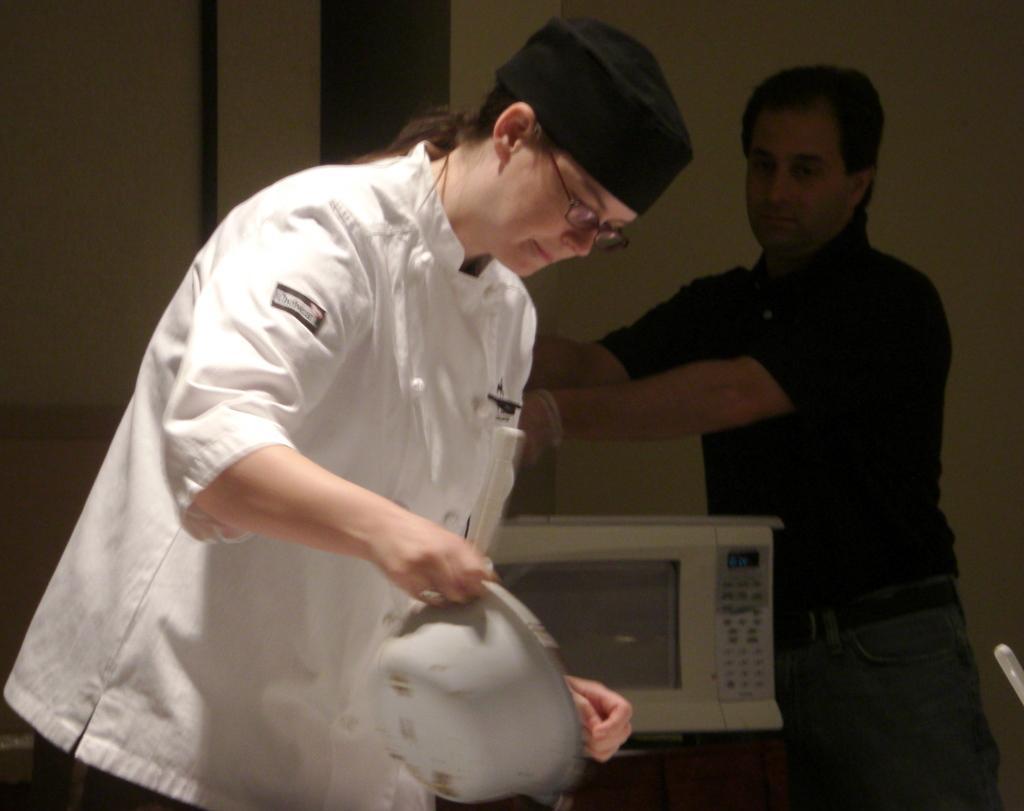Could you give a brief overview of what you see in this image? There is one woman wearing a white color dress and holding an object on the left side of this image, and there is one other person standing on the right side of this image is wearing black color t shirt. There is a microwave oven at the bottom of this image, and there is a wall in the background. 